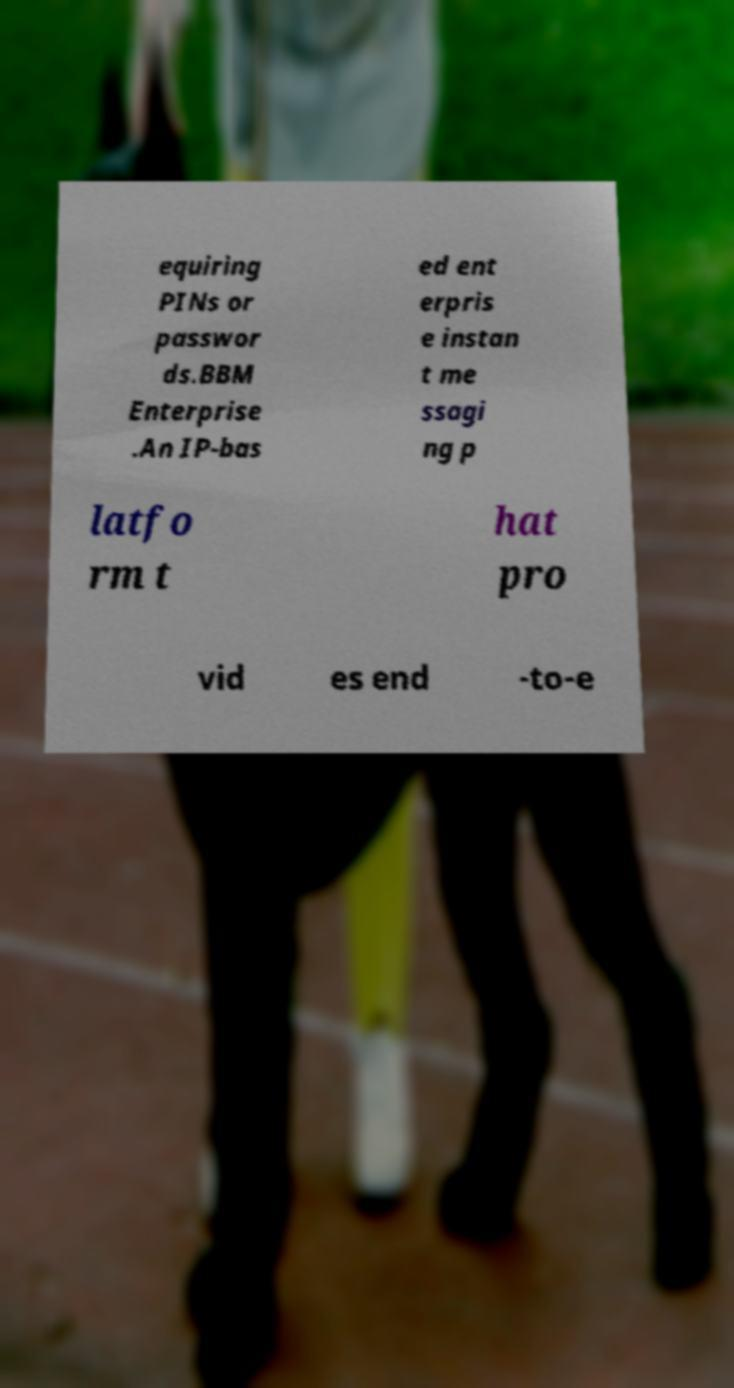Please read and relay the text visible in this image. What does it say? equiring PINs or passwor ds.BBM Enterprise .An IP-bas ed ent erpris e instan t me ssagi ng p latfo rm t hat pro vid es end -to-e 